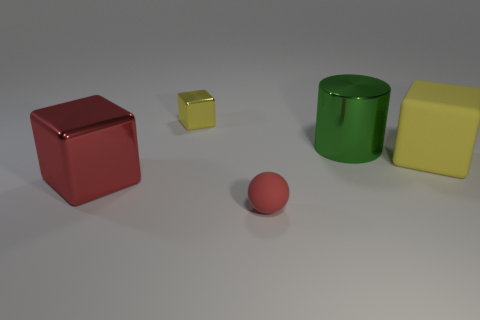Add 1 big yellow matte objects. How many objects exist? 6 Subtract all blocks. How many objects are left? 2 Subtract 0 brown cylinders. How many objects are left? 5 Subtract all large blocks. Subtract all tiny yellow shiny blocks. How many objects are left? 2 Add 5 yellow shiny things. How many yellow shiny things are left? 6 Add 2 green metallic things. How many green metallic things exist? 3 